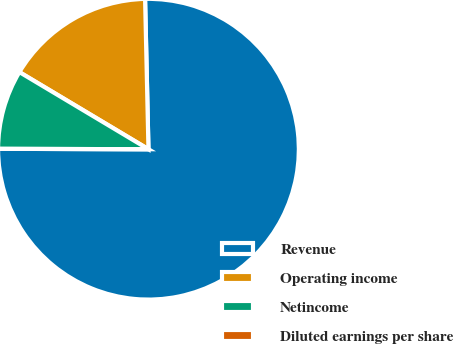Convert chart to OTSL. <chart><loc_0><loc_0><loc_500><loc_500><pie_chart><fcel>Revenue<fcel>Operating income<fcel>Netincome<fcel>Diluted earnings per share<nl><fcel>75.4%<fcel>16.07%<fcel>8.53%<fcel>0.0%<nl></chart> 